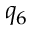Convert formula to latex. <formula><loc_0><loc_0><loc_500><loc_500>q _ { 6 }</formula> 